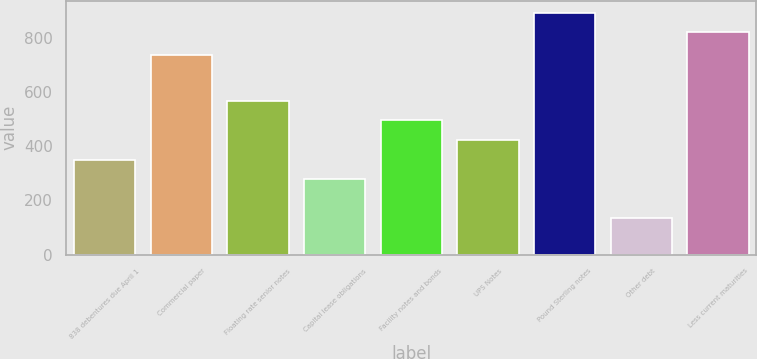Convert chart. <chart><loc_0><loc_0><loc_500><loc_500><bar_chart><fcel>838 debentures due April 1<fcel>Commercial paper<fcel>Floating rate senior notes<fcel>Capital lease obligations<fcel>Facility notes and bonds<fcel>UPS Notes<fcel>Pound Sterling notes<fcel>Other debt<fcel>Less current maturities<nl><fcel>350.8<fcel>739<fcel>569.2<fcel>278<fcel>496.4<fcel>423.6<fcel>893.8<fcel>135<fcel>821<nl></chart> 